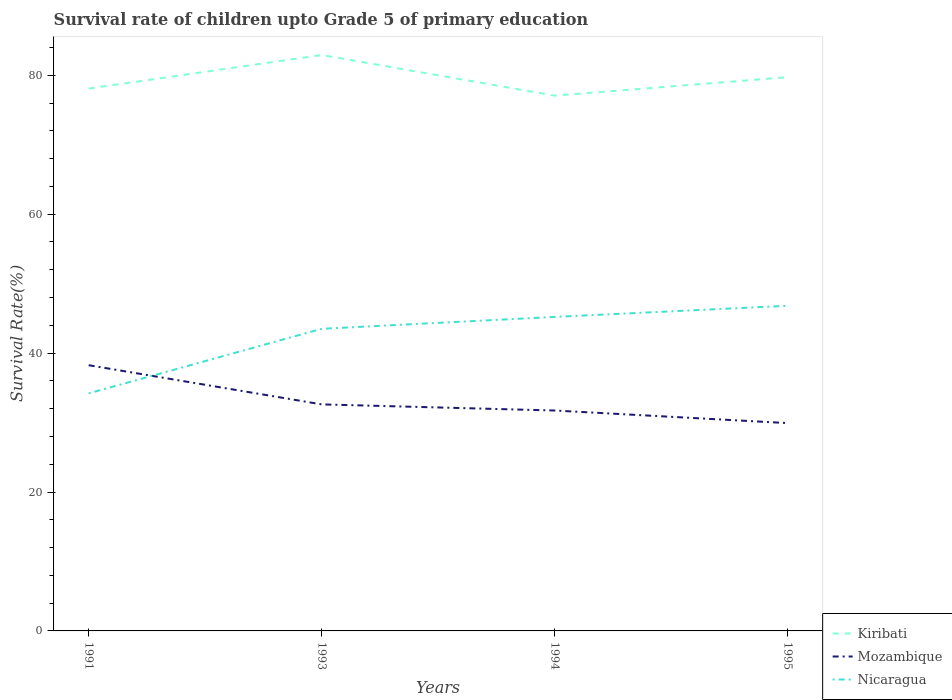How many different coloured lines are there?
Keep it short and to the point. 3. Across all years, what is the maximum survival rate of children in Mozambique?
Offer a terse response. 29.92. In which year was the survival rate of children in Mozambique maximum?
Ensure brevity in your answer.  1995. What is the total survival rate of children in Mozambique in the graph?
Make the answer very short. 1.81. What is the difference between the highest and the second highest survival rate of children in Mozambique?
Your answer should be compact. 8.34. What is the difference between the highest and the lowest survival rate of children in Mozambique?
Ensure brevity in your answer.  1. Is the survival rate of children in Mozambique strictly greater than the survival rate of children in Nicaragua over the years?
Ensure brevity in your answer.  No. What is the difference between two consecutive major ticks on the Y-axis?
Offer a very short reply. 20. Does the graph contain any zero values?
Your answer should be very brief. No. Does the graph contain grids?
Your response must be concise. No. How are the legend labels stacked?
Keep it short and to the point. Vertical. What is the title of the graph?
Give a very brief answer. Survival rate of children upto Grade 5 of primary education. Does "Small states" appear as one of the legend labels in the graph?
Make the answer very short. No. What is the label or title of the X-axis?
Your answer should be compact. Years. What is the label or title of the Y-axis?
Give a very brief answer. Survival Rate(%). What is the Survival Rate(%) in Kiribati in 1991?
Offer a terse response. 78.08. What is the Survival Rate(%) of Mozambique in 1991?
Keep it short and to the point. 38.26. What is the Survival Rate(%) of Nicaragua in 1991?
Your response must be concise. 34.2. What is the Survival Rate(%) in Kiribati in 1993?
Keep it short and to the point. 82.92. What is the Survival Rate(%) of Mozambique in 1993?
Keep it short and to the point. 32.62. What is the Survival Rate(%) in Nicaragua in 1993?
Keep it short and to the point. 43.5. What is the Survival Rate(%) of Kiribati in 1994?
Your response must be concise. 77.06. What is the Survival Rate(%) in Mozambique in 1994?
Offer a very short reply. 31.73. What is the Survival Rate(%) of Nicaragua in 1994?
Keep it short and to the point. 45.21. What is the Survival Rate(%) in Kiribati in 1995?
Your answer should be very brief. 79.73. What is the Survival Rate(%) of Mozambique in 1995?
Provide a short and direct response. 29.92. What is the Survival Rate(%) in Nicaragua in 1995?
Your answer should be compact. 46.81. Across all years, what is the maximum Survival Rate(%) of Kiribati?
Your response must be concise. 82.92. Across all years, what is the maximum Survival Rate(%) of Mozambique?
Offer a terse response. 38.26. Across all years, what is the maximum Survival Rate(%) in Nicaragua?
Keep it short and to the point. 46.81. Across all years, what is the minimum Survival Rate(%) of Kiribati?
Give a very brief answer. 77.06. Across all years, what is the minimum Survival Rate(%) in Mozambique?
Keep it short and to the point. 29.92. Across all years, what is the minimum Survival Rate(%) of Nicaragua?
Your response must be concise. 34.2. What is the total Survival Rate(%) of Kiribati in the graph?
Make the answer very short. 317.79. What is the total Survival Rate(%) of Mozambique in the graph?
Provide a short and direct response. 132.53. What is the total Survival Rate(%) of Nicaragua in the graph?
Offer a very short reply. 169.72. What is the difference between the Survival Rate(%) of Kiribati in 1991 and that in 1993?
Offer a very short reply. -4.84. What is the difference between the Survival Rate(%) in Mozambique in 1991 and that in 1993?
Make the answer very short. 5.64. What is the difference between the Survival Rate(%) in Nicaragua in 1991 and that in 1993?
Your response must be concise. -9.29. What is the difference between the Survival Rate(%) in Kiribati in 1991 and that in 1994?
Your answer should be compact. 1.02. What is the difference between the Survival Rate(%) in Mozambique in 1991 and that in 1994?
Your response must be concise. 6.53. What is the difference between the Survival Rate(%) of Nicaragua in 1991 and that in 1994?
Your answer should be compact. -11.01. What is the difference between the Survival Rate(%) of Kiribati in 1991 and that in 1995?
Provide a short and direct response. -1.65. What is the difference between the Survival Rate(%) of Mozambique in 1991 and that in 1995?
Keep it short and to the point. 8.34. What is the difference between the Survival Rate(%) of Nicaragua in 1991 and that in 1995?
Ensure brevity in your answer.  -12.61. What is the difference between the Survival Rate(%) in Kiribati in 1993 and that in 1994?
Provide a short and direct response. 5.86. What is the difference between the Survival Rate(%) in Mozambique in 1993 and that in 1994?
Make the answer very short. 0.88. What is the difference between the Survival Rate(%) in Nicaragua in 1993 and that in 1994?
Ensure brevity in your answer.  -1.71. What is the difference between the Survival Rate(%) of Kiribati in 1993 and that in 1995?
Keep it short and to the point. 3.19. What is the difference between the Survival Rate(%) of Mozambique in 1993 and that in 1995?
Your response must be concise. 2.7. What is the difference between the Survival Rate(%) in Nicaragua in 1993 and that in 1995?
Offer a very short reply. -3.32. What is the difference between the Survival Rate(%) of Kiribati in 1994 and that in 1995?
Provide a short and direct response. -2.66. What is the difference between the Survival Rate(%) in Mozambique in 1994 and that in 1995?
Provide a succinct answer. 1.81. What is the difference between the Survival Rate(%) of Nicaragua in 1994 and that in 1995?
Provide a short and direct response. -1.61. What is the difference between the Survival Rate(%) of Kiribati in 1991 and the Survival Rate(%) of Mozambique in 1993?
Your response must be concise. 45.47. What is the difference between the Survival Rate(%) in Kiribati in 1991 and the Survival Rate(%) in Nicaragua in 1993?
Ensure brevity in your answer.  34.59. What is the difference between the Survival Rate(%) in Mozambique in 1991 and the Survival Rate(%) in Nicaragua in 1993?
Your answer should be compact. -5.24. What is the difference between the Survival Rate(%) of Kiribati in 1991 and the Survival Rate(%) of Mozambique in 1994?
Ensure brevity in your answer.  46.35. What is the difference between the Survival Rate(%) in Kiribati in 1991 and the Survival Rate(%) in Nicaragua in 1994?
Give a very brief answer. 32.87. What is the difference between the Survival Rate(%) of Mozambique in 1991 and the Survival Rate(%) of Nicaragua in 1994?
Give a very brief answer. -6.95. What is the difference between the Survival Rate(%) of Kiribati in 1991 and the Survival Rate(%) of Mozambique in 1995?
Keep it short and to the point. 48.16. What is the difference between the Survival Rate(%) of Kiribati in 1991 and the Survival Rate(%) of Nicaragua in 1995?
Your answer should be very brief. 31.27. What is the difference between the Survival Rate(%) of Mozambique in 1991 and the Survival Rate(%) of Nicaragua in 1995?
Provide a succinct answer. -8.56. What is the difference between the Survival Rate(%) of Kiribati in 1993 and the Survival Rate(%) of Mozambique in 1994?
Provide a succinct answer. 51.19. What is the difference between the Survival Rate(%) of Kiribati in 1993 and the Survival Rate(%) of Nicaragua in 1994?
Make the answer very short. 37.71. What is the difference between the Survival Rate(%) of Mozambique in 1993 and the Survival Rate(%) of Nicaragua in 1994?
Provide a short and direct response. -12.59. What is the difference between the Survival Rate(%) of Kiribati in 1993 and the Survival Rate(%) of Mozambique in 1995?
Give a very brief answer. 53. What is the difference between the Survival Rate(%) in Kiribati in 1993 and the Survival Rate(%) in Nicaragua in 1995?
Your answer should be very brief. 36.11. What is the difference between the Survival Rate(%) of Mozambique in 1993 and the Survival Rate(%) of Nicaragua in 1995?
Your response must be concise. -14.2. What is the difference between the Survival Rate(%) of Kiribati in 1994 and the Survival Rate(%) of Mozambique in 1995?
Your answer should be compact. 47.14. What is the difference between the Survival Rate(%) of Kiribati in 1994 and the Survival Rate(%) of Nicaragua in 1995?
Your response must be concise. 30.25. What is the difference between the Survival Rate(%) of Mozambique in 1994 and the Survival Rate(%) of Nicaragua in 1995?
Offer a terse response. -15.08. What is the average Survival Rate(%) of Kiribati per year?
Your answer should be very brief. 79.45. What is the average Survival Rate(%) of Mozambique per year?
Your answer should be very brief. 33.13. What is the average Survival Rate(%) of Nicaragua per year?
Ensure brevity in your answer.  42.43. In the year 1991, what is the difference between the Survival Rate(%) of Kiribati and Survival Rate(%) of Mozambique?
Provide a succinct answer. 39.82. In the year 1991, what is the difference between the Survival Rate(%) of Kiribati and Survival Rate(%) of Nicaragua?
Make the answer very short. 43.88. In the year 1991, what is the difference between the Survival Rate(%) of Mozambique and Survival Rate(%) of Nicaragua?
Your response must be concise. 4.06. In the year 1993, what is the difference between the Survival Rate(%) in Kiribati and Survival Rate(%) in Mozambique?
Ensure brevity in your answer.  50.3. In the year 1993, what is the difference between the Survival Rate(%) of Kiribati and Survival Rate(%) of Nicaragua?
Offer a terse response. 39.42. In the year 1993, what is the difference between the Survival Rate(%) in Mozambique and Survival Rate(%) in Nicaragua?
Ensure brevity in your answer.  -10.88. In the year 1994, what is the difference between the Survival Rate(%) in Kiribati and Survival Rate(%) in Mozambique?
Offer a terse response. 45.33. In the year 1994, what is the difference between the Survival Rate(%) of Kiribati and Survival Rate(%) of Nicaragua?
Make the answer very short. 31.86. In the year 1994, what is the difference between the Survival Rate(%) of Mozambique and Survival Rate(%) of Nicaragua?
Offer a terse response. -13.48. In the year 1995, what is the difference between the Survival Rate(%) of Kiribati and Survival Rate(%) of Mozambique?
Your response must be concise. 49.81. In the year 1995, what is the difference between the Survival Rate(%) in Kiribati and Survival Rate(%) in Nicaragua?
Your response must be concise. 32.91. In the year 1995, what is the difference between the Survival Rate(%) of Mozambique and Survival Rate(%) of Nicaragua?
Ensure brevity in your answer.  -16.89. What is the ratio of the Survival Rate(%) in Kiribati in 1991 to that in 1993?
Your answer should be very brief. 0.94. What is the ratio of the Survival Rate(%) of Mozambique in 1991 to that in 1993?
Provide a succinct answer. 1.17. What is the ratio of the Survival Rate(%) of Nicaragua in 1991 to that in 1993?
Ensure brevity in your answer.  0.79. What is the ratio of the Survival Rate(%) of Kiribati in 1991 to that in 1994?
Keep it short and to the point. 1.01. What is the ratio of the Survival Rate(%) of Mozambique in 1991 to that in 1994?
Offer a terse response. 1.21. What is the ratio of the Survival Rate(%) in Nicaragua in 1991 to that in 1994?
Your answer should be very brief. 0.76. What is the ratio of the Survival Rate(%) of Kiribati in 1991 to that in 1995?
Ensure brevity in your answer.  0.98. What is the ratio of the Survival Rate(%) of Mozambique in 1991 to that in 1995?
Your answer should be compact. 1.28. What is the ratio of the Survival Rate(%) of Nicaragua in 1991 to that in 1995?
Offer a very short reply. 0.73. What is the ratio of the Survival Rate(%) in Kiribati in 1993 to that in 1994?
Your answer should be very brief. 1.08. What is the ratio of the Survival Rate(%) of Mozambique in 1993 to that in 1994?
Offer a terse response. 1.03. What is the ratio of the Survival Rate(%) of Nicaragua in 1993 to that in 1994?
Keep it short and to the point. 0.96. What is the ratio of the Survival Rate(%) of Mozambique in 1993 to that in 1995?
Make the answer very short. 1.09. What is the ratio of the Survival Rate(%) in Nicaragua in 1993 to that in 1995?
Offer a terse response. 0.93. What is the ratio of the Survival Rate(%) in Kiribati in 1994 to that in 1995?
Your answer should be very brief. 0.97. What is the ratio of the Survival Rate(%) in Mozambique in 1994 to that in 1995?
Provide a short and direct response. 1.06. What is the ratio of the Survival Rate(%) in Nicaragua in 1994 to that in 1995?
Offer a very short reply. 0.97. What is the difference between the highest and the second highest Survival Rate(%) of Kiribati?
Make the answer very short. 3.19. What is the difference between the highest and the second highest Survival Rate(%) in Mozambique?
Provide a succinct answer. 5.64. What is the difference between the highest and the second highest Survival Rate(%) of Nicaragua?
Make the answer very short. 1.61. What is the difference between the highest and the lowest Survival Rate(%) of Kiribati?
Keep it short and to the point. 5.86. What is the difference between the highest and the lowest Survival Rate(%) of Mozambique?
Offer a terse response. 8.34. What is the difference between the highest and the lowest Survival Rate(%) in Nicaragua?
Keep it short and to the point. 12.61. 